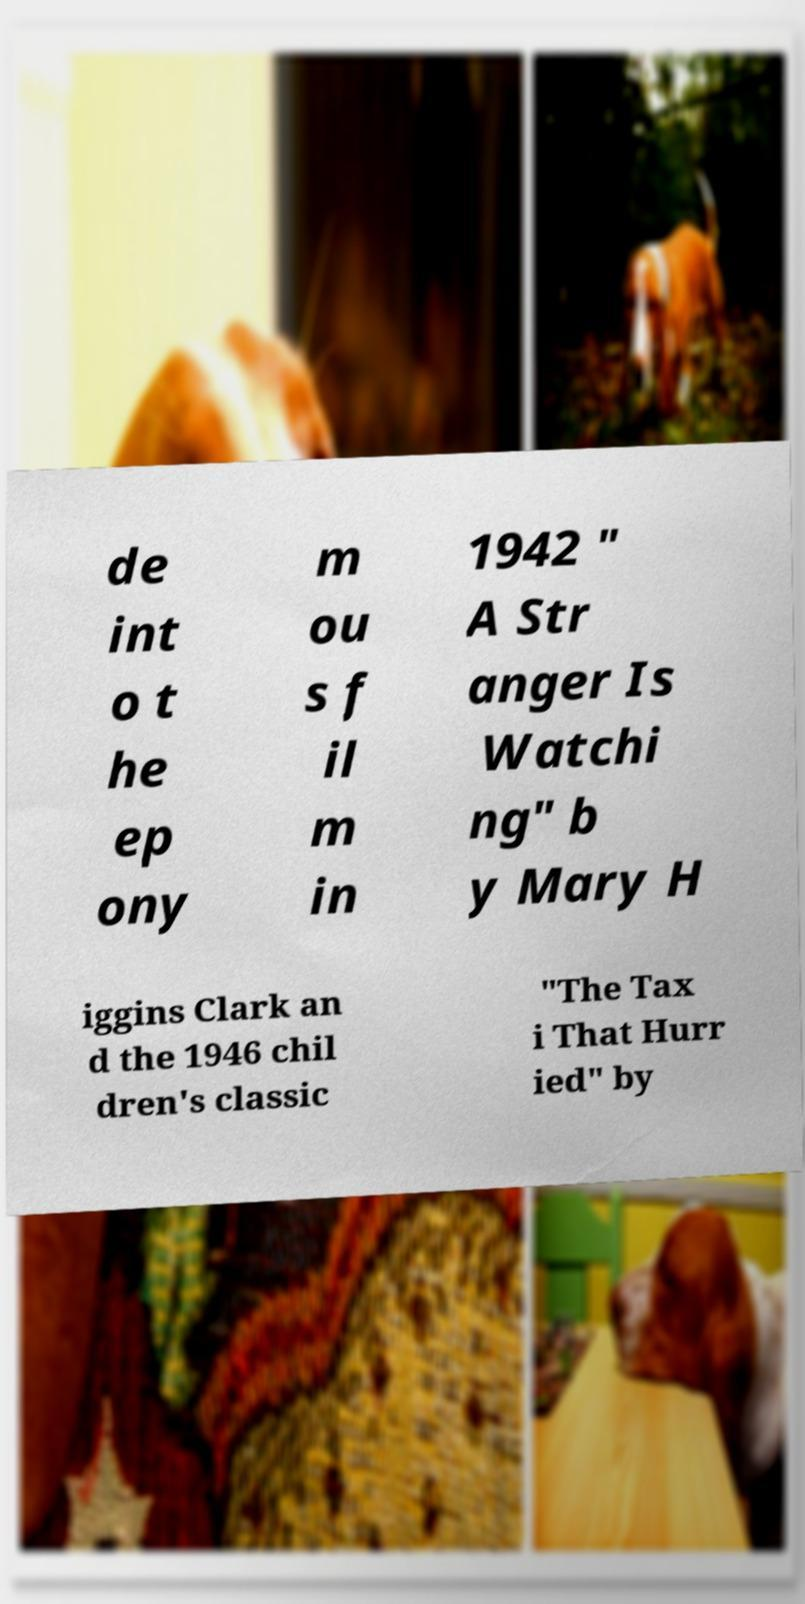Could you assist in decoding the text presented in this image and type it out clearly? de int o t he ep ony m ou s f il m in 1942 " A Str anger Is Watchi ng" b y Mary H iggins Clark an d the 1946 chil dren's classic "The Tax i That Hurr ied" by 